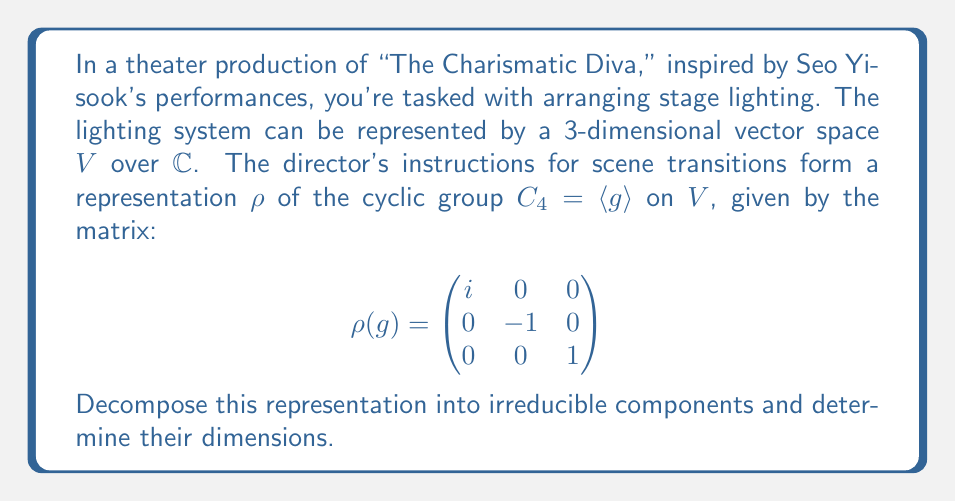Could you help me with this problem? Let's approach this step-by-step:

1) First, we need to identify the eigenvalues of $\rho(g)$. They are $i, -1,$ and $1$.

2) Each distinct eigenvalue corresponds to an irreducible subrepresentation of $C_4$. This is because $C_4$ is abelian, so all its irreducible representations are 1-dimensional.

3) Let's call these subrepresentations $V_1, V_2,$ and $V_3$ corresponding to eigenvalues $i, -1,$ and $1$ respectively.

4) The dimension of each subrepresentation is equal to the algebraic multiplicity of its corresponding eigenvalue:

   $\dim(V_1) = 1$ (eigenvalue $i$)
   $\dim(V_2) = 1$ (eigenvalue $-1$)
   $\dim(V_3) = 1$ (eigenvalue $1$)

5) We can write the decomposition as:

   $V = V_1 \oplus V_2 \oplus V_3$

6) To verify, we can check that the sum of dimensions matches:

   $\dim(V) = \dim(V_1) + \dim(V_2) + \dim(V_3) = 1 + 1 + 1 = 3$

Therefore, the representation decomposes into three 1-dimensional irreducible components.
Answer: $V = V_1 \oplus V_2 \oplus V_3$, where $\dim(V_1) = \dim(V_2) = \dim(V_3) = 1$ 